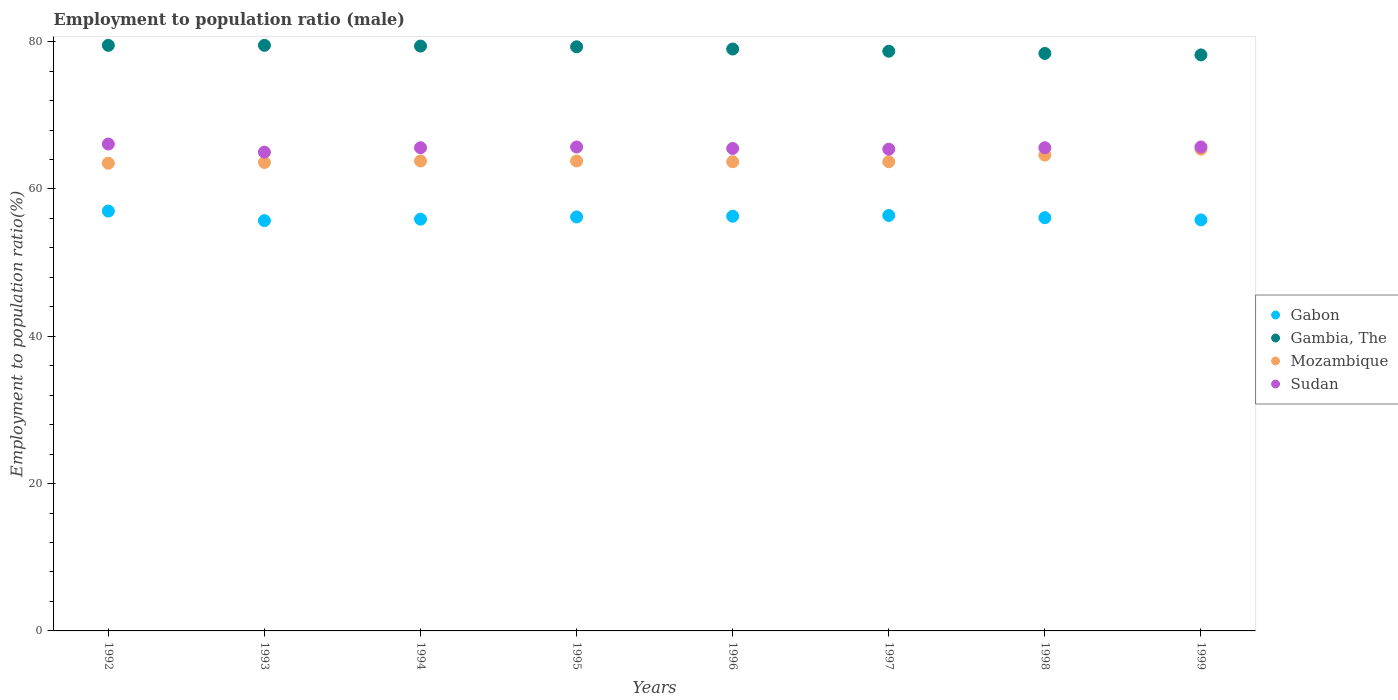Is the number of dotlines equal to the number of legend labels?
Ensure brevity in your answer.  Yes. What is the employment to population ratio in Sudan in 1999?
Your answer should be compact. 65.7. Across all years, what is the maximum employment to population ratio in Mozambique?
Offer a very short reply. 65.4. Across all years, what is the minimum employment to population ratio in Sudan?
Offer a terse response. 65. In which year was the employment to population ratio in Gambia, The minimum?
Ensure brevity in your answer.  1999. What is the total employment to population ratio in Mozambique in the graph?
Ensure brevity in your answer.  512.1. What is the difference between the employment to population ratio in Sudan in 1994 and that in 1997?
Offer a terse response. 0.2. What is the difference between the employment to population ratio in Sudan in 1998 and the employment to population ratio in Gabon in 1996?
Offer a terse response. 9.3. What is the average employment to population ratio in Sudan per year?
Provide a short and direct response. 65.57. In the year 1999, what is the difference between the employment to population ratio in Gabon and employment to population ratio in Mozambique?
Give a very brief answer. -9.6. What is the ratio of the employment to population ratio in Sudan in 1994 to that in 1999?
Provide a succinct answer. 1. Is the difference between the employment to population ratio in Gabon in 1993 and 1999 greater than the difference between the employment to population ratio in Mozambique in 1993 and 1999?
Give a very brief answer. Yes. What is the difference between the highest and the second highest employment to population ratio in Sudan?
Provide a short and direct response. 0.4. What is the difference between the highest and the lowest employment to population ratio in Sudan?
Ensure brevity in your answer.  1.1. In how many years, is the employment to population ratio in Mozambique greater than the average employment to population ratio in Mozambique taken over all years?
Offer a terse response. 2. Is the employment to population ratio in Mozambique strictly greater than the employment to population ratio in Sudan over the years?
Make the answer very short. No. How many years are there in the graph?
Provide a succinct answer. 8. What is the difference between two consecutive major ticks on the Y-axis?
Ensure brevity in your answer.  20. Are the values on the major ticks of Y-axis written in scientific E-notation?
Provide a succinct answer. No. Does the graph contain any zero values?
Your answer should be very brief. No. Where does the legend appear in the graph?
Keep it short and to the point. Center right. How many legend labels are there?
Your response must be concise. 4. What is the title of the graph?
Provide a succinct answer. Employment to population ratio (male). What is the label or title of the X-axis?
Keep it short and to the point. Years. What is the Employment to population ratio(%) in Gambia, The in 1992?
Offer a very short reply. 79.5. What is the Employment to population ratio(%) in Mozambique in 1992?
Make the answer very short. 63.5. What is the Employment to population ratio(%) in Sudan in 1992?
Keep it short and to the point. 66.1. What is the Employment to population ratio(%) in Gabon in 1993?
Your answer should be very brief. 55.7. What is the Employment to population ratio(%) of Gambia, The in 1993?
Ensure brevity in your answer.  79.5. What is the Employment to population ratio(%) in Mozambique in 1993?
Provide a succinct answer. 63.6. What is the Employment to population ratio(%) of Sudan in 1993?
Your answer should be compact. 65. What is the Employment to population ratio(%) of Gabon in 1994?
Keep it short and to the point. 55.9. What is the Employment to population ratio(%) of Gambia, The in 1994?
Make the answer very short. 79.4. What is the Employment to population ratio(%) of Mozambique in 1994?
Provide a succinct answer. 63.8. What is the Employment to population ratio(%) in Sudan in 1994?
Offer a terse response. 65.6. What is the Employment to population ratio(%) of Gabon in 1995?
Give a very brief answer. 56.2. What is the Employment to population ratio(%) of Gambia, The in 1995?
Ensure brevity in your answer.  79.3. What is the Employment to population ratio(%) in Mozambique in 1995?
Make the answer very short. 63.8. What is the Employment to population ratio(%) of Sudan in 1995?
Make the answer very short. 65.7. What is the Employment to population ratio(%) of Gabon in 1996?
Give a very brief answer. 56.3. What is the Employment to population ratio(%) in Gambia, The in 1996?
Offer a terse response. 79. What is the Employment to population ratio(%) in Mozambique in 1996?
Your response must be concise. 63.7. What is the Employment to population ratio(%) of Sudan in 1996?
Ensure brevity in your answer.  65.5. What is the Employment to population ratio(%) of Gabon in 1997?
Offer a terse response. 56.4. What is the Employment to population ratio(%) in Gambia, The in 1997?
Your answer should be very brief. 78.7. What is the Employment to population ratio(%) in Mozambique in 1997?
Your answer should be compact. 63.7. What is the Employment to population ratio(%) of Sudan in 1997?
Your answer should be compact. 65.4. What is the Employment to population ratio(%) of Gabon in 1998?
Offer a terse response. 56.1. What is the Employment to population ratio(%) in Gambia, The in 1998?
Offer a very short reply. 78.4. What is the Employment to population ratio(%) in Mozambique in 1998?
Offer a very short reply. 64.6. What is the Employment to population ratio(%) of Sudan in 1998?
Your response must be concise. 65.6. What is the Employment to population ratio(%) of Gabon in 1999?
Offer a terse response. 55.8. What is the Employment to population ratio(%) of Gambia, The in 1999?
Provide a succinct answer. 78.2. What is the Employment to population ratio(%) of Mozambique in 1999?
Your answer should be compact. 65.4. What is the Employment to population ratio(%) in Sudan in 1999?
Provide a short and direct response. 65.7. Across all years, what is the maximum Employment to population ratio(%) of Gambia, The?
Provide a succinct answer. 79.5. Across all years, what is the maximum Employment to population ratio(%) in Mozambique?
Keep it short and to the point. 65.4. Across all years, what is the maximum Employment to population ratio(%) in Sudan?
Give a very brief answer. 66.1. Across all years, what is the minimum Employment to population ratio(%) in Gabon?
Offer a very short reply. 55.7. Across all years, what is the minimum Employment to population ratio(%) in Gambia, The?
Make the answer very short. 78.2. Across all years, what is the minimum Employment to population ratio(%) in Mozambique?
Offer a very short reply. 63.5. Across all years, what is the minimum Employment to population ratio(%) in Sudan?
Offer a terse response. 65. What is the total Employment to population ratio(%) in Gabon in the graph?
Give a very brief answer. 449.4. What is the total Employment to population ratio(%) in Gambia, The in the graph?
Provide a succinct answer. 632. What is the total Employment to population ratio(%) of Mozambique in the graph?
Offer a terse response. 512.1. What is the total Employment to population ratio(%) of Sudan in the graph?
Provide a short and direct response. 524.6. What is the difference between the Employment to population ratio(%) of Mozambique in 1992 and that in 1993?
Offer a very short reply. -0.1. What is the difference between the Employment to population ratio(%) of Sudan in 1992 and that in 1993?
Keep it short and to the point. 1.1. What is the difference between the Employment to population ratio(%) in Gambia, The in 1992 and that in 1994?
Provide a succinct answer. 0.1. What is the difference between the Employment to population ratio(%) of Gabon in 1992 and that in 1995?
Offer a very short reply. 0.8. What is the difference between the Employment to population ratio(%) in Mozambique in 1992 and that in 1995?
Your response must be concise. -0.3. What is the difference between the Employment to population ratio(%) of Gabon in 1992 and that in 1996?
Your response must be concise. 0.7. What is the difference between the Employment to population ratio(%) in Gambia, The in 1992 and that in 1996?
Ensure brevity in your answer.  0.5. What is the difference between the Employment to population ratio(%) of Gambia, The in 1992 and that in 1997?
Keep it short and to the point. 0.8. What is the difference between the Employment to population ratio(%) in Sudan in 1992 and that in 1997?
Give a very brief answer. 0.7. What is the difference between the Employment to population ratio(%) of Gabon in 1992 and that in 1998?
Ensure brevity in your answer.  0.9. What is the difference between the Employment to population ratio(%) in Gambia, The in 1992 and that in 1998?
Give a very brief answer. 1.1. What is the difference between the Employment to population ratio(%) of Mozambique in 1992 and that in 1998?
Provide a short and direct response. -1.1. What is the difference between the Employment to population ratio(%) of Gambia, The in 1992 and that in 1999?
Give a very brief answer. 1.3. What is the difference between the Employment to population ratio(%) in Sudan in 1992 and that in 1999?
Offer a terse response. 0.4. What is the difference between the Employment to population ratio(%) of Gambia, The in 1993 and that in 1994?
Offer a terse response. 0.1. What is the difference between the Employment to population ratio(%) in Gabon in 1993 and that in 1995?
Keep it short and to the point. -0.5. What is the difference between the Employment to population ratio(%) of Mozambique in 1993 and that in 1995?
Give a very brief answer. -0.2. What is the difference between the Employment to population ratio(%) in Gambia, The in 1993 and that in 1996?
Your answer should be very brief. 0.5. What is the difference between the Employment to population ratio(%) in Gabon in 1993 and that in 1997?
Ensure brevity in your answer.  -0.7. What is the difference between the Employment to population ratio(%) of Gambia, The in 1993 and that in 1997?
Provide a short and direct response. 0.8. What is the difference between the Employment to population ratio(%) in Sudan in 1993 and that in 1997?
Ensure brevity in your answer.  -0.4. What is the difference between the Employment to population ratio(%) in Gabon in 1993 and that in 1998?
Give a very brief answer. -0.4. What is the difference between the Employment to population ratio(%) of Gambia, The in 1993 and that in 1998?
Provide a short and direct response. 1.1. What is the difference between the Employment to population ratio(%) in Gabon in 1993 and that in 1999?
Provide a succinct answer. -0.1. What is the difference between the Employment to population ratio(%) in Gambia, The in 1994 and that in 1995?
Provide a short and direct response. 0.1. What is the difference between the Employment to population ratio(%) in Sudan in 1994 and that in 1995?
Provide a succinct answer. -0.1. What is the difference between the Employment to population ratio(%) of Gambia, The in 1994 and that in 1996?
Your answer should be compact. 0.4. What is the difference between the Employment to population ratio(%) of Sudan in 1994 and that in 1996?
Provide a succinct answer. 0.1. What is the difference between the Employment to population ratio(%) of Gabon in 1994 and that in 1997?
Provide a short and direct response. -0.5. What is the difference between the Employment to population ratio(%) of Gambia, The in 1994 and that in 1997?
Offer a very short reply. 0.7. What is the difference between the Employment to population ratio(%) of Sudan in 1994 and that in 1997?
Your answer should be compact. 0.2. What is the difference between the Employment to population ratio(%) in Mozambique in 1994 and that in 1998?
Your response must be concise. -0.8. What is the difference between the Employment to population ratio(%) in Sudan in 1994 and that in 1998?
Offer a terse response. 0. What is the difference between the Employment to population ratio(%) of Gambia, The in 1994 and that in 1999?
Your answer should be compact. 1.2. What is the difference between the Employment to population ratio(%) in Mozambique in 1994 and that in 1999?
Make the answer very short. -1.6. What is the difference between the Employment to population ratio(%) in Gabon in 1995 and that in 1996?
Your answer should be very brief. -0.1. What is the difference between the Employment to population ratio(%) of Gambia, The in 1995 and that in 1997?
Provide a succinct answer. 0.6. What is the difference between the Employment to population ratio(%) of Mozambique in 1995 and that in 1997?
Ensure brevity in your answer.  0.1. What is the difference between the Employment to population ratio(%) in Gabon in 1995 and that in 1998?
Your response must be concise. 0.1. What is the difference between the Employment to population ratio(%) in Gambia, The in 1995 and that in 1998?
Keep it short and to the point. 0.9. What is the difference between the Employment to population ratio(%) of Gabon in 1995 and that in 1999?
Your answer should be very brief. 0.4. What is the difference between the Employment to population ratio(%) in Gabon in 1996 and that in 1997?
Your answer should be compact. -0.1. What is the difference between the Employment to population ratio(%) in Sudan in 1996 and that in 1997?
Your response must be concise. 0.1. What is the difference between the Employment to population ratio(%) in Gambia, The in 1996 and that in 1998?
Offer a very short reply. 0.6. What is the difference between the Employment to population ratio(%) in Mozambique in 1996 and that in 1999?
Provide a short and direct response. -1.7. What is the difference between the Employment to population ratio(%) in Sudan in 1996 and that in 1999?
Your answer should be very brief. -0.2. What is the difference between the Employment to population ratio(%) in Mozambique in 1997 and that in 1998?
Ensure brevity in your answer.  -0.9. What is the difference between the Employment to population ratio(%) of Sudan in 1997 and that in 1998?
Offer a very short reply. -0.2. What is the difference between the Employment to population ratio(%) of Gambia, The in 1997 and that in 1999?
Keep it short and to the point. 0.5. What is the difference between the Employment to population ratio(%) of Gabon in 1998 and that in 1999?
Ensure brevity in your answer.  0.3. What is the difference between the Employment to population ratio(%) of Gambia, The in 1998 and that in 1999?
Your answer should be very brief. 0.2. What is the difference between the Employment to population ratio(%) of Gabon in 1992 and the Employment to population ratio(%) of Gambia, The in 1993?
Provide a short and direct response. -22.5. What is the difference between the Employment to population ratio(%) in Gabon in 1992 and the Employment to population ratio(%) in Mozambique in 1993?
Make the answer very short. -6.6. What is the difference between the Employment to population ratio(%) in Gabon in 1992 and the Employment to population ratio(%) in Sudan in 1993?
Make the answer very short. -8. What is the difference between the Employment to population ratio(%) in Mozambique in 1992 and the Employment to population ratio(%) in Sudan in 1993?
Offer a terse response. -1.5. What is the difference between the Employment to population ratio(%) in Gabon in 1992 and the Employment to population ratio(%) in Gambia, The in 1994?
Your answer should be compact. -22.4. What is the difference between the Employment to population ratio(%) in Gambia, The in 1992 and the Employment to population ratio(%) in Mozambique in 1994?
Ensure brevity in your answer.  15.7. What is the difference between the Employment to population ratio(%) of Mozambique in 1992 and the Employment to population ratio(%) of Sudan in 1994?
Ensure brevity in your answer.  -2.1. What is the difference between the Employment to population ratio(%) in Gabon in 1992 and the Employment to population ratio(%) in Gambia, The in 1995?
Your answer should be compact. -22.3. What is the difference between the Employment to population ratio(%) in Gabon in 1992 and the Employment to population ratio(%) in Sudan in 1995?
Keep it short and to the point. -8.7. What is the difference between the Employment to population ratio(%) of Gambia, The in 1992 and the Employment to population ratio(%) of Mozambique in 1995?
Keep it short and to the point. 15.7. What is the difference between the Employment to population ratio(%) in Gabon in 1992 and the Employment to population ratio(%) in Mozambique in 1996?
Offer a terse response. -6.7. What is the difference between the Employment to population ratio(%) in Gambia, The in 1992 and the Employment to population ratio(%) in Mozambique in 1996?
Provide a succinct answer. 15.8. What is the difference between the Employment to population ratio(%) of Mozambique in 1992 and the Employment to population ratio(%) of Sudan in 1996?
Provide a succinct answer. -2. What is the difference between the Employment to population ratio(%) in Gabon in 1992 and the Employment to population ratio(%) in Gambia, The in 1997?
Your response must be concise. -21.7. What is the difference between the Employment to population ratio(%) of Mozambique in 1992 and the Employment to population ratio(%) of Sudan in 1997?
Your response must be concise. -1.9. What is the difference between the Employment to population ratio(%) in Gabon in 1992 and the Employment to population ratio(%) in Gambia, The in 1998?
Make the answer very short. -21.4. What is the difference between the Employment to population ratio(%) of Gabon in 1992 and the Employment to population ratio(%) of Sudan in 1998?
Provide a short and direct response. -8.6. What is the difference between the Employment to population ratio(%) of Gambia, The in 1992 and the Employment to population ratio(%) of Mozambique in 1998?
Ensure brevity in your answer.  14.9. What is the difference between the Employment to population ratio(%) in Gabon in 1992 and the Employment to population ratio(%) in Gambia, The in 1999?
Keep it short and to the point. -21.2. What is the difference between the Employment to population ratio(%) in Gabon in 1992 and the Employment to population ratio(%) in Sudan in 1999?
Your response must be concise. -8.7. What is the difference between the Employment to population ratio(%) of Gambia, The in 1992 and the Employment to population ratio(%) of Mozambique in 1999?
Ensure brevity in your answer.  14.1. What is the difference between the Employment to population ratio(%) of Gambia, The in 1992 and the Employment to population ratio(%) of Sudan in 1999?
Make the answer very short. 13.8. What is the difference between the Employment to population ratio(%) of Mozambique in 1992 and the Employment to population ratio(%) of Sudan in 1999?
Your answer should be very brief. -2.2. What is the difference between the Employment to population ratio(%) in Gabon in 1993 and the Employment to population ratio(%) in Gambia, The in 1994?
Provide a short and direct response. -23.7. What is the difference between the Employment to population ratio(%) of Mozambique in 1993 and the Employment to population ratio(%) of Sudan in 1994?
Provide a succinct answer. -2. What is the difference between the Employment to population ratio(%) of Gabon in 1993 and the Employment to population ratio(%) of Gambia, The in 1995?
Your response must be concise. -23.6. What is the difference between the Employment to population ratio(%) in Gabon in 1993 and the Employment to population ratio(%) in Mozambique in 1995?
Keep it short and to the point. -8.1. What is the difference between the Employment to population ratio(%) in Gabon in 1993 and the Employment to population ratio(%) in Gambia, The in 1996?
Make the answer very short. -23.3. What is the difference between the Employment to population ratio(%) in Gabon in 1993 and the Employment to population ratio(%) in Mozambique in 1996?
Your response must be concise. -8. What is the difference between the Employment to population ratio(%) of Gabon in 1993 and the Employment to population ratio(%) of Gambia, The in 1997?
Make the answer very short. -23. What is the difference between the Employment to population ratio(%) of Gabon in 1993 and the Employment to population ratio(%) of Sudan in 1997?
Provide a short and direct response. -9.7. What is the difference between the Employment to population ratio(%) of Gambia, The in 1993 and the Employment to population ratio(%) of Mozambique in 1997?
Your answer should be compact. 15.8. What is the difference between the Employment to population ratio(%) of Mozambique in 1993 and the Employment to population ratio(%) of Sudan in 1997?
Your response must be concise. -1.8. What is the difference between the Employment to population ratio(%) in Gabon in 1993 and the Employment to population ratio(%) in Gambia, The in 1998?
Ensure brevity in your answer.  -22.7. What is the difference between the Employment to population ratio(%) of Gabon in 1993 and the Employment to population ratio(%) of Sudan in 1998?
Provide a short and direct response. -9.9. What is the difference between the Employment to population ratio(%) of Gambia, The in 1993 and the Employment to population ratio(%) of Mozambique in 1998?
Provide a succinct answer. 14.9. What is the difference between the Employment to population ratio(%) in Mozambique in 1993 and the Employment to population ratio(%) in Sudan in 1998?
Ensure brevity in your answer.  -2. What is the difference between the Employment to population ratio(%) in Gabon in 1993 and the Employment to population ratio(%) in Gambia, The in 1999?
Make the answer very short. -22.5. What is the difference between the Employment to population ratio(%) in Gabon in 1994 and the Employment to population ratio(%) in Gambia, The in 1995?
Your answer should be compact. -23.4. What is the difference between the Employment to population ratio(%) of Gabon in 1994 and the Employment to population ratio(%) of Sudan in 1995?
Provide a succinct answer. -9.8. What is the difference between the Employment to population ratio(%) in Gambia, The in 1994 and the Employment to population ratio(%) in Mozambique in 1995?
Provide a succinct answer. 15.6. What is the difference between the Employment to population ratio(%) in Gabon in 1994 and the Employment to population ratio(%) in Gambia, The in 1996?
Your answer should be compact. -23.1. What is the difference between the Employment to population ratio(%) of Gabon in 1994 and the Employment to population ratio(%) of Mozambique in 1996?
Offer a very short reply. -7.8. What is the difference between the Employment to population ratio(%) in Gabon in 1994 and the Employment to population ratio(%) in Sudan in 1996?
Provide a short and direct response. -9.6. What is the difference between the Employment to population ratio(%) in Gambia, The in 1994 and the Employment to population ratio(%) in Sudan in 1996?
Give a very brief answer. 13.9. What is the difference between the Employment to population ratio(%) in Gabon in 1994 and the Employment to population ratio(%) in Gambia, The in 1997?
Your answer should be very brief. -22.8. What is the difference between the Employment to population ratio(%) of Gabon in 1994 and the Employment to population ratio(%) of Mozambique in 1997?
Provide a succinct answer. -7.8. What is the difference between the Employment to population ratio(%) of Gambia, The in 1994 and the Employment to population ratio(%) of Sudan in 1997?
Provide a short and direct response. 14. What is the difference between the Employment to population ratio(%) of Mozambique in 1994 and the Employment to population ratio(%) of Sudan in 1997?
Make the answer very short. -1.6. What is the difference between the Employment to population ratio(%) of Gabon in 1994 and the Employment to population ratio(%) of Gambia, The in 1998?
Offer a terse response. -22.5. What is the difference between the Employment to population ratio(%) in Gabon in 1994 and the Employment to population ratio(%) in Sudan in 1998?
Provide a succinct answer. -9.7. What is the difference between the Employment to population ratio(%) in Gambia, The in 1994 and the Employment to population ratio(%) in Sudan in 1998?
Provide a succinct answer. 13.8. What is the difference between the Employment to population ratio(%) in Mozambique in 1994 and the Employment to population ratio(%) in Sudan in 1998?
Your response must be concise. -1.8. What is the difference between the Employment to population ratio(%) in Gabon in 1994 and the Employment to population ratio(%) in Gambia, The in 1999?
Make the answer very short. -22.3. What is the difference between the Employment to population ratio(%) of Mozambique in 1994 and the Employment to population ratio(%) of Sudan in 1999?
Provide a succinct answer. -1.9. What is the difference between the Employment to population ratio(%) of Gabon in 1995 and the Employment to population ratio(%) of Gambia, The in 1996?
Provide a short and direct response. -22.8. What is the difference between the Employment to population ratio(%) in Gabon in 1995 and the Employment to population ratio(%) in Mozambique in 1996?
Provide a succinct answer. -7.5. What is the difference between the Employment to population ratio(%) of Gambia, The in 1995 and the Employment to population ratio(%) of Mozambique in 1996?
Ensure brevity in your answer.  15.6. What is the difference between the Employment to population ratio(%) of Gambia, The in 1995 and the Employment to population ratio(%) of Sudan in 1996?
Your answer should be compact. 13.8. What is the difference between the Employment to population ratio(%) in Mozambique in 1995 and the Employment to population ratio(%) in Sudan in 1996?
Keep it short and to the point. -1.7. What is the difference between the Employment to population ratio(%) of Gabon in 1995 and the Employment to population ratio(%) of Gambia, The in 1997?
Make the answer very short. -22.5. What is the difference between the Employment to population ratio(%) in Gabon in 1995 and the Employment to population ratio(%) in Mozambique in 1997?
Give a very brief answer. -7.5. What is the difference between the Employment to population ratio(%) in Gabon in 1995 and the Employment to population ratio(%) in Sudan in 1997?
Offer a very short reply. -9.2. What is the difference between the Employment to population ratio(%) in Mozambique in 1995 and the Employment to population ratio(%) in Sudan in 1997?
Ensure brevity in your answer.  -1.6. What is the difference between the Employment to population ratio(%) in Gabon in 1995 and the Employment to population ratio(%) in Gambia, The in 1998?
Provide a short and direct response. -22.2. What is the difference between the Employment to population ratio(%) of Gabon in 1995 and the Employment to population ratio(%) of Sudan in 1998?
Your response must be concise. -9.4. What is the difference between the Employment to population ratio(%) of Gambia, The in 1995 and the Employment to population ratio(%) of Mozambique in 1998?
Your answer should be compact. 14.7. What is the difference between the Employment to population ratio(%) of Gambia, The in 1995 and the Employment to population ratio(%) of Sudan in 1998?
Ensure brevity in your answer.  13.7. What is the difference between the Employment to population ratio(%) in Gabon in 1995 and the Employment to population ratio(%) in Gambia, The in 1999?
Keep it short and to the point. -22. What is the difference between the Employment to population ratio(%) of Gambia, The in 1995 and the Employment to population ratio(%) of Mozambique in 1999?
Keep it short and to the point. 13.9. What is the difference between the Employment to population ratio(%) in Gabon in 1996 and the Employment to population ratio(%) in Gambia, The in 1997?
Your response must be concise. -22.4. What is the difference between the Employment to population ratio(%) of Gabon in 1996 and the Employment to population ratio(%) of Sudan in 1997?
Your answer should be very brief. -9.1. What is the difference between the Employment to population ratio(%) in Gabon in 1996 and the Employment to population ratio(%) in Gambia, The in 1998?
Offer a terse response. -22.1. What is the difference between the Employment to population ratio(%) in Gabon in 1996 and the Employment to population ratio(%) in Mozambique in 1998?
Provide a succinct answer. -8.3. What is the difference between the Employment to population ratio(%) in Mozambique in 1996 and the Employment to population ratio(%) in Sudan in 1998?
Offer a terse response. -1.9. What is the difference between the Employment to population ratio(%) in Gabon in 1996 and the Employment to population ratio(%) in Gambia, The in 1999?
Your response must be concise. -21.9. What is the difference between the Employment to population ratio(%) of Gambia, The in 1996 and the Employment to population ratio(%) of Mozambique in 1999?
Give a very brief answer. 13.6. What is the difference between the Employment to population ratio(%) in Gambia, The in 1996 and the Employment to population ratio(%) in Sudan in 1999?
Ensure brevity in your answer.  13.3. What is the difference between the Employment to population ratio(%) of Gabon in 1997 and the Employment to population ratio(%) of Sudan in 1998?
Give a very brief answer. -9.2. What is the difference between the Employment to population ratio(%) in Gambia, The in 1997 and the Employment to population ratio(%) in Mozambique in 1998?
Your answer should be compact. 14.1. What is the difference between the Employment to population ratio(%) of Mozambique in 1997 and the Employment to population ratio(%) of Sudan in 1998?
Make the answer very short. -1.9. What is the difference between the Employment to population ratio(%) of Gabon in 1997 and the Employment to population ratio(%) of Gambia, The in 1999?
Ensure brevity in your answer.  -21.8. What is the difference between the Employment to population ratio(%) of Mozambique in 1997 and the Employment to population ratio(%) of Sudan in 1999?
Make the answer very short. -2. What is the difference between the Employment to population ratio(%) of Gabon in 1998 and the Employment to population ratio(%) of Gambia, The in 1999?
Your answer should be very brief. -22.1. What is the difference between the Employment to population ratio(%) in Gabon in 1998 and the Employment to population ratio(%) in Mozambique in 1999?
Keep it short and to the point. -9.3. What is the difference between the Employment to population ratio(%) in Gabon in 1998 and the Employment to population ratio(%) in Sudan in 1999?
Offer a terse response. -9.6. What is the difference between the Employment to population ratio(%) of Gambia, The in 1998 and the Employment to population ratio(%) of Sudan in 1999?
Your answer should be compact. 12.7. What is the average Employment to population ratio(%) of Gabon per year?
Offer a terse response. 56.17. What is the average Employment to population ratio(%) of Gambia, The per year?
Make the answer very short. 79. What is the average Employment to population ratio(%) in Mozambique per year?
Provide a succinct answer. 64.01. What is the average Employment to population ratio(%) in Sudan per year?
Your response must be concise. 65.58. In the year 1992, what is the difference between the Employment to population ratio(%) in Gabon and Employment to population ratio(%) in Gambia, The?
Provide a short and direct response. -22.5. In the year 1992, what is the difference between the Employment to population ratio(%) of Gabon and Employment to population ratio(%) of Mozambique?
Give a very brief answer. -6.5. In the year 1992, what is the difference between the Employment to population ratio(%) of Gambia, The and Employment to population ratio(%) of Mozambique?
Your response must be concise. 16. In the year 1992, what is the difference between the Employment to population ratio(%) in Mozambique and Employment to population ratio(%) in Sudan?
Your response must be concise. -2.6. In the year 1993, what is the difference between the Employment to population ratio(%) in Gabon and Employment to population ratio(%) in Gambia, The?
Your answer should be very brief. -23.8. In the year 1993, what is the difference between the Employment to population ratio(%) of Gambia, The and Employment to population ratio(%) of Sudan?
Your answer should be very brief. 14.5. In the year 1994, what is the difference between the Employment to population ratio(%) in Gabon and Employment to population ratio(%) in Gambia, The?
Ensure brevity in your answer.  -23.5. In the year 1994, what is the difference between the Employment to population ratio(%) in Gabon and Employment to population ratio(%) in Mozambique?
Provide a succinct answer. -7.9. In the year 1994, what is the difference between the Employment to population ratio(%) of Gabon and Employment to population ratio(%) of Sudan?
Offer a terse response. -9.7. In the year 1995, what is the difference between the Employment to population ratio(%) in Gabon and Employment to population ratio(%) in Gambia, The?
Offer a terse response. -23.1. In the year 1995, what is the difference between the Employment to population ratio(%) in Gambia, The and Employment to population ratio(%) in Mozambique?
Make the answer very short. 15.5. In the year 1995, what is the difference between the Employment to population ratio(%) of Gambia, The and Employment to population ratio(%) of Sudan?
Your response must be concise. 13.6. In the year 1996, what is the difference between the Employment to population ratio(%) in Gabon and Employment to population ratio(%) in Gambia, The?
Make the answer very short. -22.7. In the year 1996, what is the difference between the Employment to population ratio(%) in Gabon and Employment to population ratio(%) in Mozambique?
Your answer should be compact. -7.4. In the year 1996, what is the difference between the Employment to population ratio(%) of Gabon and Employment to population ratio(%) of Sudan?
Ensure brevity in your answer.  -9.2. In the year 1997, what is the difference between the Employment to population ratio(%) of Gabon and Employment to population ratio(%) of Gambia, The?
Give a very brief answer. -22.3. In the year 1997, what is the difference between the Employment to population ratio(%) in Gabon and Employment to population ratio(%) in Mozambique?
Give a very brief answer. -7.3. In the year 1997, what is the difference between the Employment to population ratio(%) of Gabon and Employment to population ratio(%) of Sudan?
Provide a succinct answer. -9. In the year 1997, what is the difference between the Employment to population ratio(%) of Gambia, The and Employment to population ratio(%) of Mozambique?
Your answer should be very brief. 15. In the year 1997, what is the difference between the Employment to population ratio(%) in Mozambique and Employment to population ratio(%) in Sudan?
Offer a very short reply. -1.7. In the year 1998, what is the difference between the Employment to population ratio(%) in Gabon and Employment to population ratio(%) in Gambia, The?
Offer a very short reply. -22.3. In the year 1998, what is the difference between the Employment to population ratio(%) in Gabon and Employment to population ratio(%) in Sudan?
Provide a succinct answer. -9.5. In the year 1998, what is the difference between the Employment to population ratio(%) in Gambia, The and Employment to population ratio(%) in Sudan?
Give a very brief answer. 12.8. In the year 1999, what is the difference between the Employment to population ratio(%) in Gabon and Employment to population ratio(%) in Gambia, The?
Ensure brevity in your answer.  -22.4. In the year 1999, what is the difference between the Employment to population ratio(%) in Gambia, The and Employment to population ratio(%) in Mozambique?
Your answer should be very brief. 12.8. In the year 1999, what is the difference between the Employment to population ratio(%) of Mozambique and Employment to population ratio(%) of Sudan?
Provide a short and direct response. -0.3. What is the ratio of the Employment to population ratio(%) in Gabon in 1992 to that in 1993?
Offer a terse response. 1.02. What is the ratio of the Employment to population ratio(%) in Sudan in 1992 to that in 1993?
Make the answer very short. 1.02. What is the ratio of the Employment to population ratio(%) in Gabon in 1992 to that in 1994?
Provide a short and direct response. 1.02. What is the ratio of the Employment to population ratio(%) in Sudan in 1992 to that in 1994?
Ensure brevity in your answer.  1.01. What is the ratio of the Employment to population ratio(%) of Gabon in 1992 to that in 1995?
Give a very brief answer. 1.01. What is the ratio of the Employment to population ratio(%) of Gabon in 1992 to that in 1996?
Offer a very short reply. 1.01. What is the ratio of the Employment to population ratio(%) in Sudan in 1992 to that in 1996?
Your answer should be very brief. 1.01. What is the ratio of the Employment to population ratio(%) of Gabon in 1992 to that in 1997?
Make the answer very short. 1.01. What is the ratio of the Employment to population ratio(%) of Gambia, The in 1992 to that in 1997?
Provide a succinct answer. 1.01. What is the ratio of the Employment to population ratio(%) of Mozambique in 1992 to that in 1997?
Give a very brief answer. 1. What is the ratio of the Employment to population ratio(%) of Sudan in 1992 to that in 1997?
Ensure brevity in your answer.  1.01. What is the ratio of the Employment to population ratio(%) in Gabon in 1992 to that in 1998?
Provide a short and direct response. 1.02. What is the ratio of the Employment to population ratio(%) in Gambia, The in 1992 to that in 1998?
Provide a short and direct response. 1.01. What is the ratio of the Employment to population ratio(%) of Sudan in 1992 to that in 1998?
Provide a short and direct response. 1.01. What is the ratio of the Employment to population ratio(%) in Gabon in 1992 to that in 1999?
Your answer should be compact. 1.02. What is the ratio of the Employment to population ratio(%) of Gambia, The in 1992 to that in 1999?
Your answer should be very brief. 1.02. What is the ratio of the Employment to population ratio(%) of Mozambique in 1992 to that in 1999?
Keep it short and to the point. 0.97. What is the ratio of the Employment to population ratio(%) in Sudan in 1992 to that in 1999?
Offer a terse response. 1.01. What is the ratio of the Employment to population ratio(%) in Gabon in 1993 to that in 1994?
Provide a succinct answer. 1. What is the ratio of the Employment to population ratio(%) in Sudan in 1993 to that in 1994?
Your response must be concise. 0.99. What is the ratio of the Employment to population ratio(%) of Gabon in 1993 to that in 1995?
Your answer should be compact. 0.99. What is the ratio of the Employment to population ratio(%) of Gambia, The in 1993 to that in 1995?
Provide a succinct answer. 1. What is the ratio of the Employment to population ratio(%) in Mozambique in 1993 to that in 1995?
Provide a short and direct response. 1. What is the ratio of the Employment to population ratio(%) of Sudan in 1993 to that in 1995?
Make the answer very short. 0.99. What is the ratio of the Employment to population ratio(%) of Gabon in 1993 to that in 1996?
Provide a short and direct response. 0.99. What is the ratio of the Employment to population ratio(%) of Mozambique in 1993 to that in 1996?
Provide a short and direct response. 1. What is the ratio of the Employment to population ratio(%) of Sudan in 1993 to that in 1996?
Offer a very short reply. 0.99. What is the ratio of the Employment to population ratio(%) in Gabon in 1993 to that in 1997?
Your answer should be compact. 0.99. What is the ratio of the Employment to population ratio(%) of Gambia, The in 1993 to that in 1997?
Ensure brevity in your answer.  1.01. What is the ratio of the Employment to population ratio(%) in Sudan in 1993 to that in 1997?
Your answer should be very brief. 0.99. What is the ratio of the Employment to population ratio(%) in Gabon in 1993 to that in 1998?
Your response must be concise. 0.99. What is the ratio of the Employment to population ratio(%) in Gambia, The in 1993 to that in 1998?
Keep it short and to the point. 1.01. What is the ratio of the Employment to population ratio(%) in Mozambique in 1993 to that in 1998?
Your answer should be very brief. 0.98. What is the ratio of the Employment to population ratio(%) of Sudan in 1993 to that in 1998?
Offer a very short reply. 0.99. What is the ratio of the Employment to population ratio(%) in Gambia, The in 1993 to that in 1999?
Ensure brevity in your answer.  1.02. What is the ratio of the Employment to population ratio(%) of Mozambique in 1993 to that in 1999?
Your answer should be very brief. 0.97. What is the ratio of the Employment to population ratio(%) of Sudan in 1993 to that in 1999?
Ensure brevity in your answer.  0.99. What is the ratio of the Employment to population ratio(%) in Gambia, The in 1994 to that in 1995?
Provide a succinct answer. 1. What is the ratio of the Employment to population ratio(%) of Gabon in 1994 to that in 1996?
Keep it short and to the point. 0.99. What is the ratio of the Employment to population ratio(%) of Gambia, The in 1994 to that in 1996?
Make the answer very short. 1.01. What is the ratio of the Employment to population ratio(%) in Mozambique in 1994 to that in 1996?
Ensure brevity in your answer.  1. What is the ratio of the Employment to population ratio(%) in Sudan in 1994 to that in 1996?
Your answer should be compact. 1. What is the ratio of the Employment to population ratio(%) of Gabon in 1994 to that in 1997?
Make the answer very short. 0.99. What is the ratio of the Employment to population ratio(%) in Gambia, The in 1994 to that in 1997?
Give a very brief answer. 1.01. What is the ratio of the Employment to population ratio(%) of Sudan in 1994 to that in 1997?
Keep it short and to the point. 1. What is the ratio of the Employment to population ratio(%) in Gambia, The in 1994 to that in 1998?
Offer a very short reply. 1.01. What is the ratio of the Employment to population ratio(%) in Mozambique in 1994 to that in 1998?
Offer a very short reply. 0.99. What is the ratio of the Employment to population ratio(%) of Gambia, The in 1994 to that in 1999?
Give a very brief answer. 1.02. What is the ratio of the Employment to population ratio(%) of Mozambique in 1994 to that in 1999?
Make the answer very short. 0.98. What is the ratio of the Employment to population ratio(%) of Gabon in 1995 to that in 1996?
Your answer should be compact. 1. What is the ratio of the Employment to population ratio(%) in Gambia, The in 1995 to that in 1996?
Your answer should be very brief. 1. What is the ratio of the Employment to population ratio(%) in Mozambique in 1995 to that in 1996?
Provide a succinct answer. 1. What is the ratio of the Employment to population ratio(%) of Gabon in 1995 to that in 1997?
Give a very brief answer. 1. What is the ratio of the Employment to population ratio(%) in Gambia, The in 1995 to that in 1997?
Keep it short and to the point. 1.01. What is the ratio of the Employment to population ratio(%) of Sudan in 1995 to that in 1997?
Provide a succinct answer. 1. What is the ratio of the Employment to population ratio(%) of Gambia, The in 1995 to that in 1998?
Your answer should be very brief. 1.01. What is the ratio of the Employment to population ratio(%) of Mozambique in 1995 to that in 1998?
Offer a very short reply. 0.99. What is the ratio of the Employment to population ratio(%) in Gambia, The in 1995 to that in 1999?
Offer a very short reply. 1.01. What is the ratio of the Employment to population ratio(%) in Mozambique in 1995 to that in 1999?
Keep it short and to the point. 0.98. What is the ratio of the Employment to population ratio(%) of Gabon in 1996 to that in 1997?
Offer a terse response. 1. What is the ratio of the Employment to population ratio(%) in Sudan in 1996 to that in 1997?
Your response must be concise. 1. What is the ratio of the Employment to population ratio(%) in Gambia, The in 1996 to that in 1998?
Provide a succinct answer. 1.01. What is the ratio of the Employment to population ratio(%) in Mozambique in 1996 to that in 1998?
Keep it short and to the point. 0.99. What is the ratio of the Employment to population ratio(%) of Gabon in 1996 to that in 1999?
Your answer should be very brief. 1.01. What is the ratio of the Employment to population ratio(%) in Gambia, The in 1996 to that in 1999?
Make the answer very short. 1.01. What is the ratio of the Employment to population ratio(%) of Sudan in 1996 to that in 1999?
Offer a terse response. 1. What is the ratio of the Employment to population ratio(%) of Gambia, The in 1997 to that in 1998?
Make the answer very short. 1. What is the ratio of the Employment to population ratio(%) of Mozambique in 1997 to that in 1998?
Your answer should be very brief. 0.99. What is the ratio of the Employment to population ratio(%) of Gabon in 1997 to that in 1999?
Provide a succinct answer. 1.01. What is the ratio of the Employment to population ratio(%) in Gambia, The in 1997 to that in 1999?
Provide a short and direct response. 1.01. What is the ratio of the Employment to population ratio(%) in Gabon in 1998 to that in 1999?
Your response must be concise. 1.01. What is the ratio of the Employment to population ratio(%) of Gambia, The in 1998 to that in 1999?
Give a very brief answer. 1. What is the ratio of the Employment to population ratio(%) in Sudan in 1998 to that in 1999?
Offer a terse response. 1. What is the difference between the highest and the second highest Employment to population ratio(%) of Gambia, The?
Your response must be concise. 0. What is the difference between the highest and the second highest Employment to population ratio(%) of Sudan?
Give a very brief answer. 0.4. What is the difference between the highest and the lowest Employment to population ratio(%) of Gabon?
Provide a succinct answer. 1.3. What is the difference between the highest and the lowest Employment to population ratio(%) in Mozambique?
Your answer should be very brief. 1.9. 